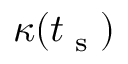<formula> <loc_0><loc_0><loc_500><loc_500>\kappa ( t _ { s } )</formula> 